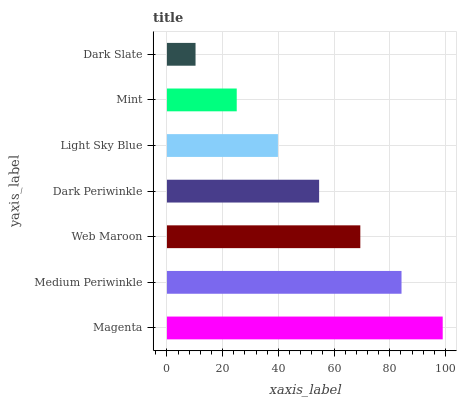Is Dark Slate the minimum?
Answer yes or no. Yes. Is Magenta the maximum?
Answer yes or no. Yes. Is Medium Periwinkle the minimum?
Answer yes or no. No. Is Medium Periwinkle the maximum?
Answer yes or no. No. Is Magenta greater than Medium Periwinkle?
Answer yes or no. Yes. Is Medium Periwinkle less than Magenta?
Answer yes or no. Yes. Is Medium Periwinkle greater than Magenta?
Answer yes or no. No. Is Magenta less than Medium Periwinkle?
Answer yes or no. No. Is Dark Periwinkle the high median?
Answer yes or no. Yes. Is Dark Periwinkle the low median?
Answer yes or no. Yes. Is Web Maroon the high median?
Answer yes or no. No. Is Mint the low median?
Answer yes or no. No. 